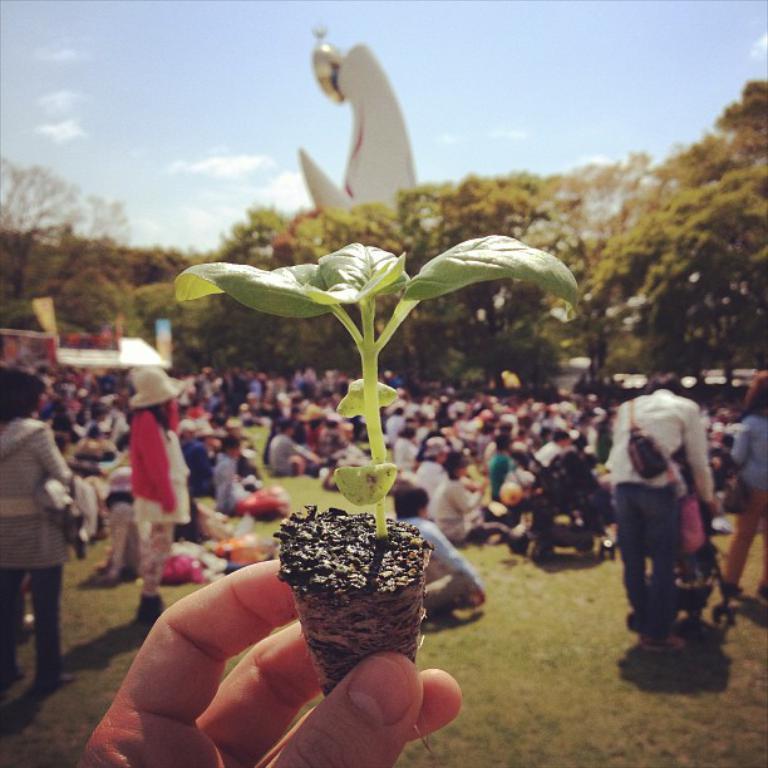In one or two sentences, can you explain what this image depicts? In this image we can see a person holding a plant and there are some people in the background and we can see some trees. There is a structure which looks like a statue and we can see the sky at the top. 